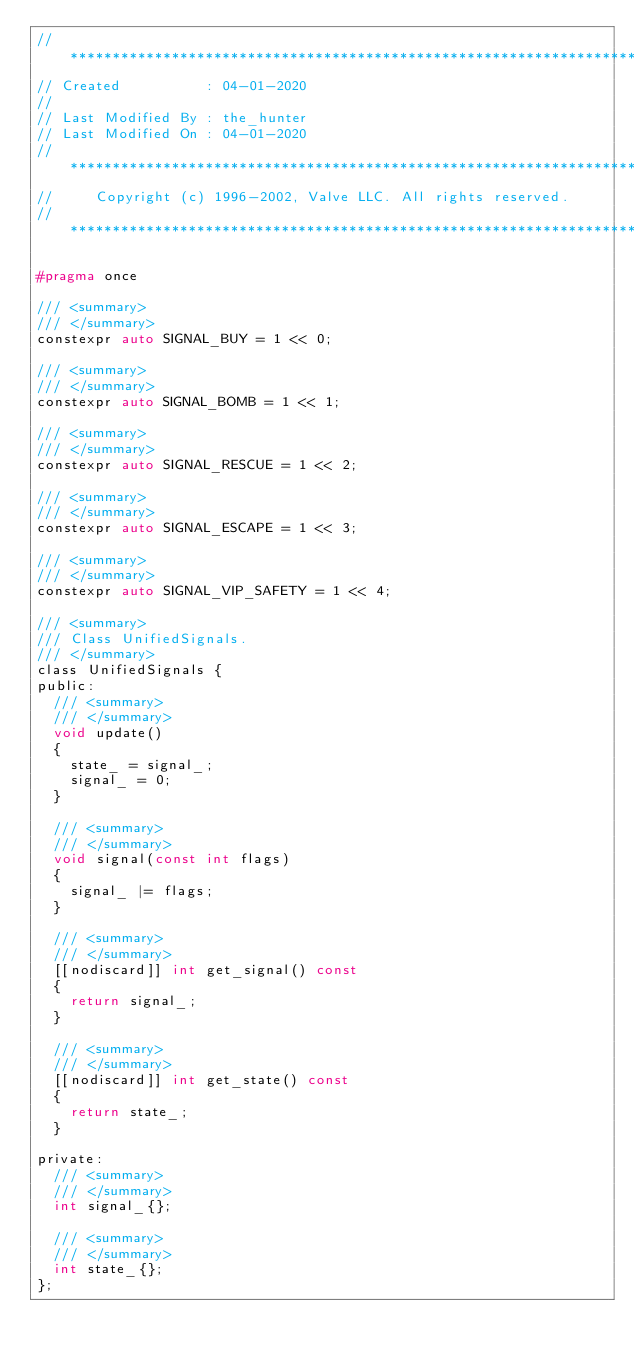<code> <loc_0><loc_0><loc_500><loc_500><_C_>// ***********************************************************************
// Created          : 04-01-2020
//
// Last Modified By : the_hunter
// Last Modified On : 04-01-2020
// ***********************************************************************
//     Copyright (c) 1996-2002, Valve LLC. All rights reserved.
// ***********************************************************************

#pragma once

/// <summary>
/// </summary>
constexpr auto SIGNAL_BUY = 1 << 0;

/// <summary>
/// </summary>
constexpr auto SIGNAL_BOMB = 1 << 1;

/// <summary>
/// </summary>
constexpr auto SIGNAL_RESCUE = 1 << 2;

/// <summary>
/// </summary>
constexpr auto SIGNAL_ESCAPE = 1 << 3;

/// <summary>
/// </summary>
constexpr auto SIGNAL_VIP_SAFETY = 1 << 4;

/// <summary>
/// Class UnifiedSignals.
/// </summary>
class UnifiedSignals {
public:
	/// <summary>
	/// </summary>
	void update()
	{
		state_ = signal_;
		signal_ = 0;
	}

	/// <summary>
	/// </summary>
	void signal(const int flags)
	{
		signal_ |= flags;
	}

	/// <summary>
	/// </summary>
	[[nodiscard]] int get_signal() const
	{
		return signal_;
	}

	/// <summary>
	/// </summary>
	[[nodiscard]] int get_state() const
	{
		return state_;
	}

private:
	/// <summary>
	/// </summary>
	int signal_{};

	/// <summary>
	/// </summary>
	int state_{};
};
</code> 